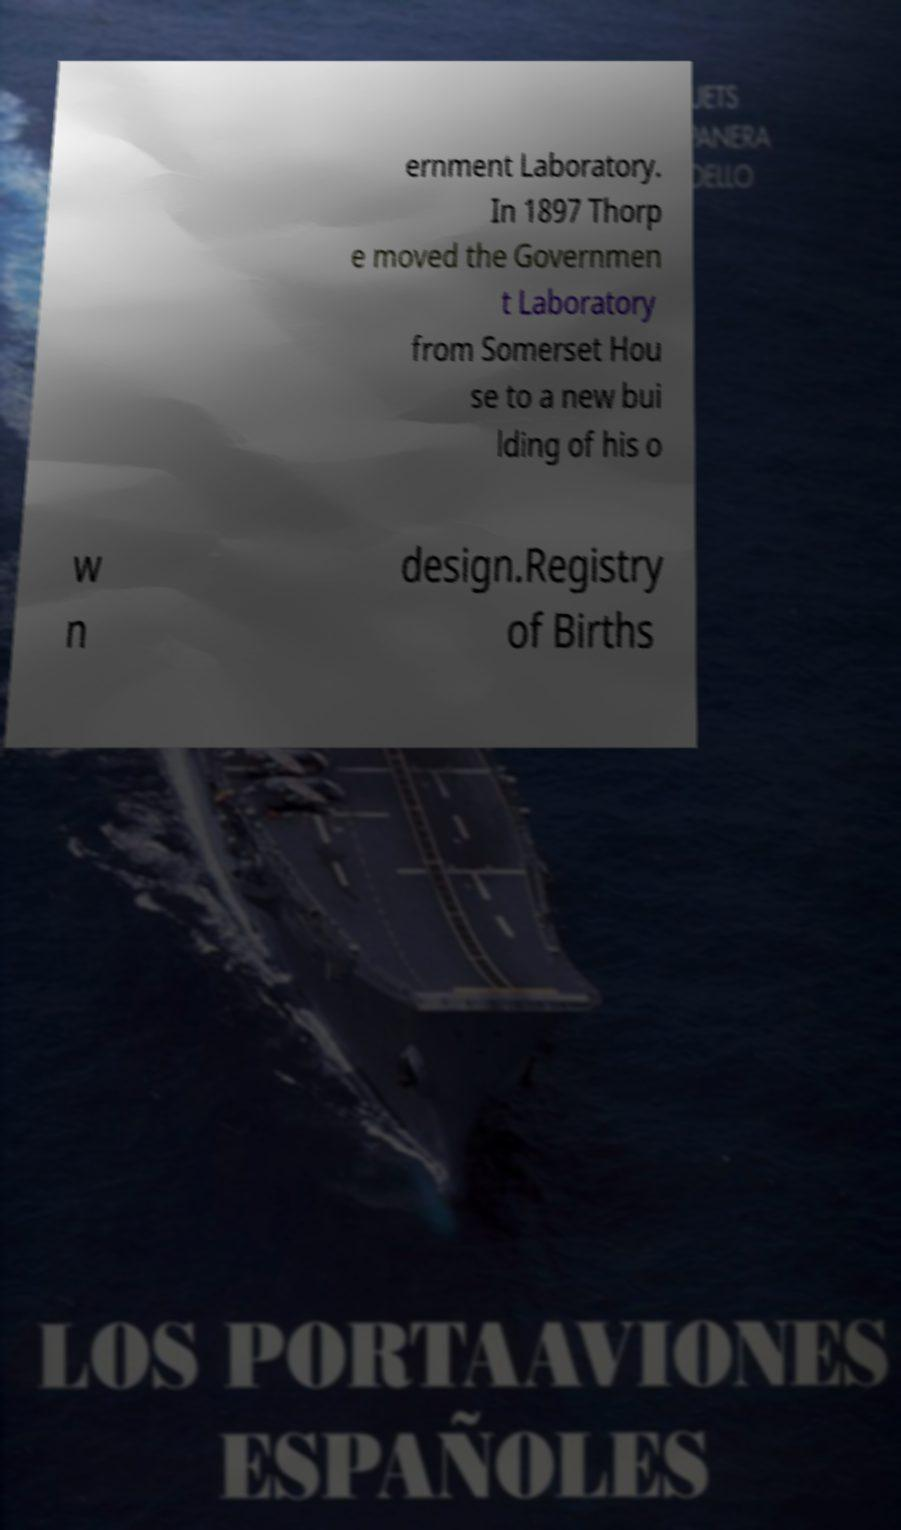What messages or text are displayed in this image? I need them in a readable, typed format. ernment Laboratory. In 1897 Thorp e moved the Governmen t Laboratory from Somerset Hou se to a new bui lding of his o w n design.Registry of Births 